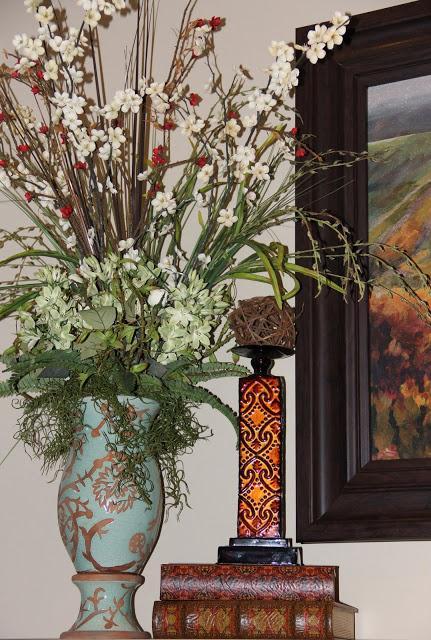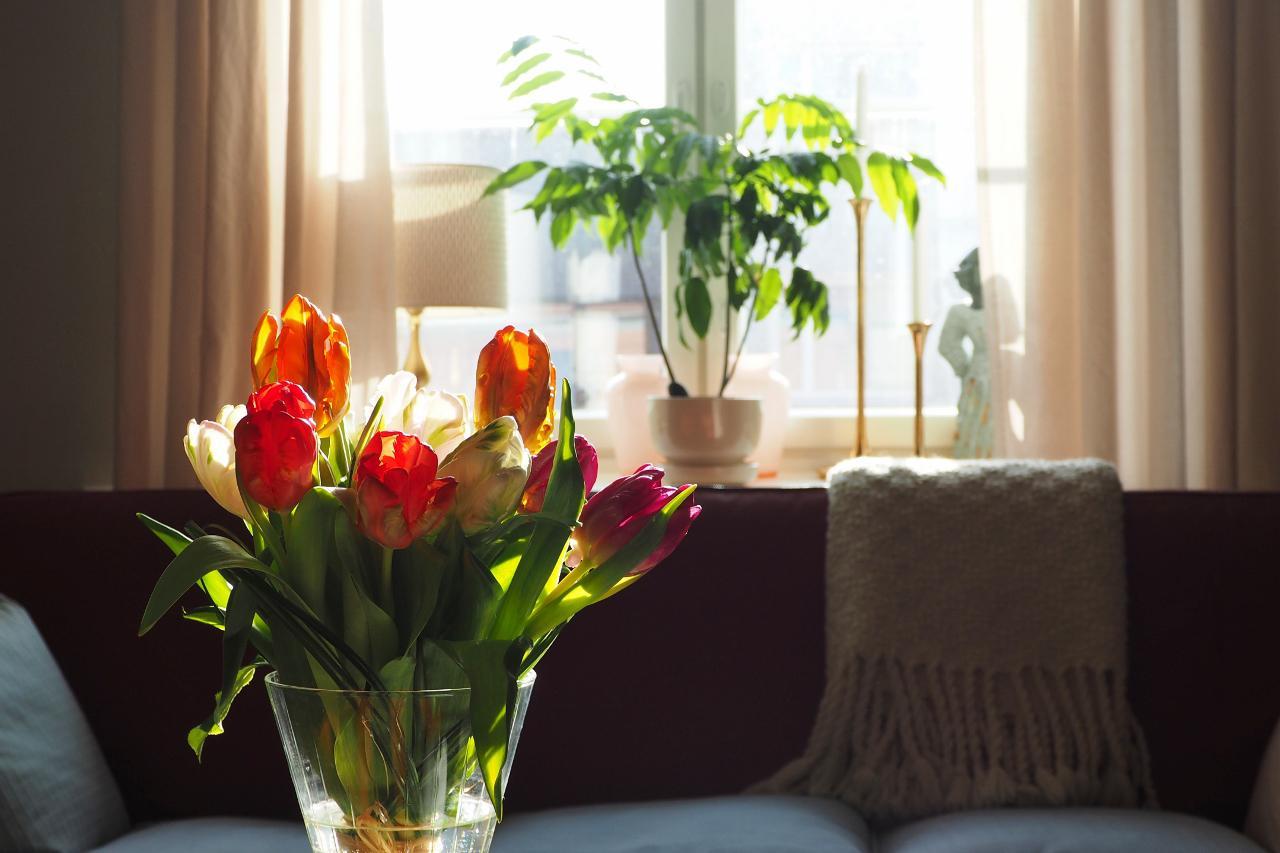The first image is the image on the left, the second image is the image on the right. For the images shown, is this caption "There is a clear glass vase with red tulips in one image and a bouquet in a different kind of container in the second image." true? Answer yes or no. Yes. The first image is the image on the left, the second image is the image on the right. Analyze the images presented: Is the assertion "A clear glass vase of yellow and orange tulips is near a sofa in front of a window." valid? Answer yes or no. Yes. 